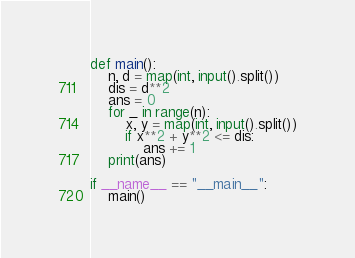Convert code to text. <code><loc_0><loc_0><loc_500><loc_500><_Python_>def main():
    n, d = map(int, input().split())
    dis = d**2
    ans = 0
    for _ in range(n):
        x, y = map(int, input().split())
        if x**2 + y**2 <= dis:
            ans += 1
    print(ans)

if __name__ == "__main__":
    main()</code> 